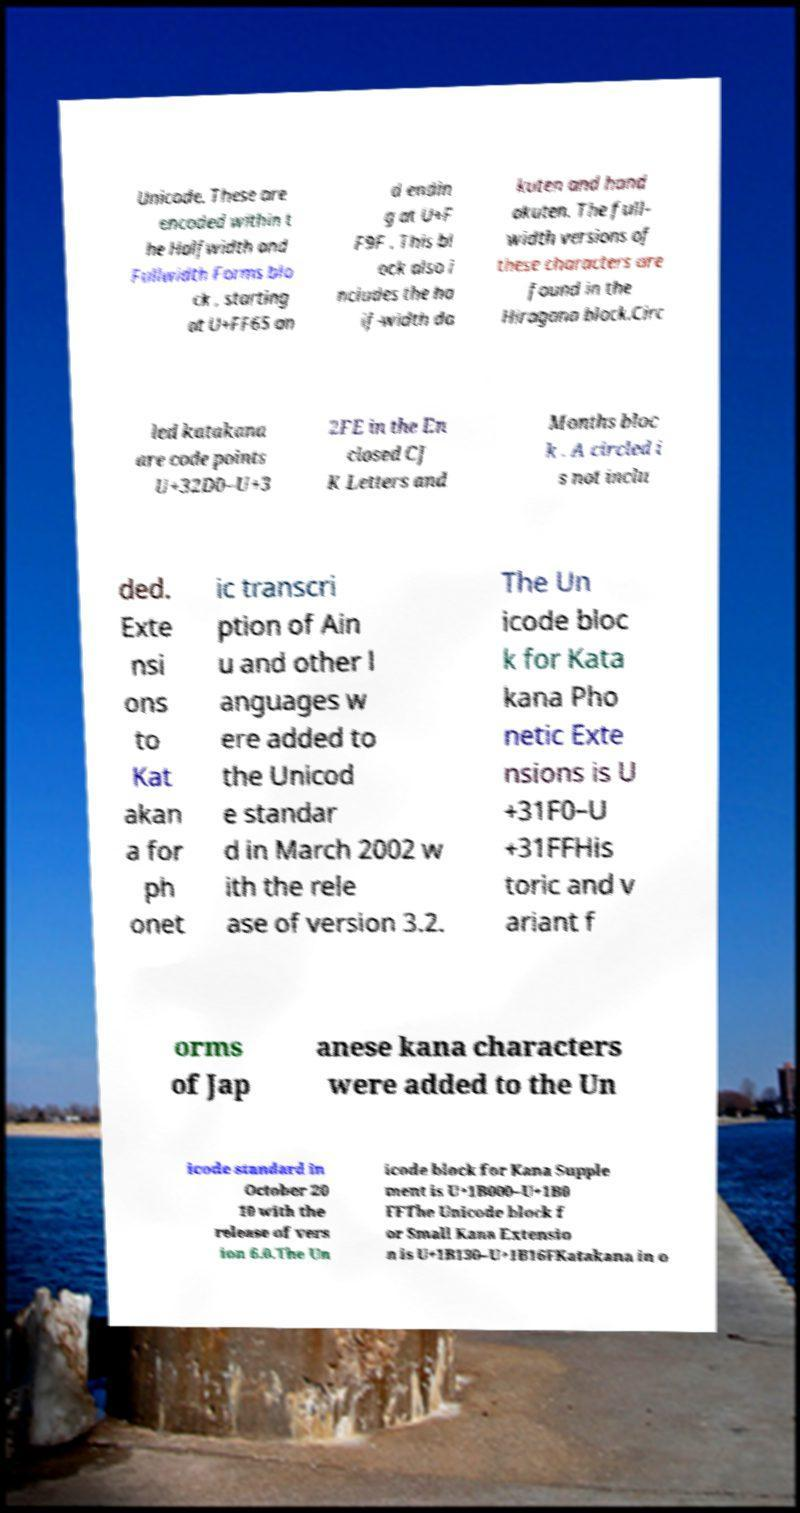Please identify and transcribe the text found in this image. Unicode. These are encoded within t he Halfwidth and Fullwidth Forms blo ck , starting at U+FF65 an d endin g at U+F F9F . This bl ock also i ncludes the ha lf-width da kuten and hand akuten. The full- width versions of these characters are found in the Hiragana block.Circ led katakana are code points U+32D0–U+3 2FE in the En closed CJ K Letters and Months bloc k . A circled i s not inclu ded. Exte nsi ons to Kat akan a for ph onet ic transcri ption of Ain u and other l anguages w ere added to the Unicod e standar d in March 2002 w ith the rele ase of version 3.2. The Un icode bloc k for Kata kana Pho netic Exte nsions is U +31F0–U +31FFHis toric and v ariant f orms of Jap anese kana characters were added to the Un icode standard in October 20 10 with the release of vers ion 6.0.The Un icode block for Kana Supple ment is U+1B000–U+1B0 FFThe Unicode block f or Small Kana Extensio n is U+1B130–U+1B16FKatakana in o 